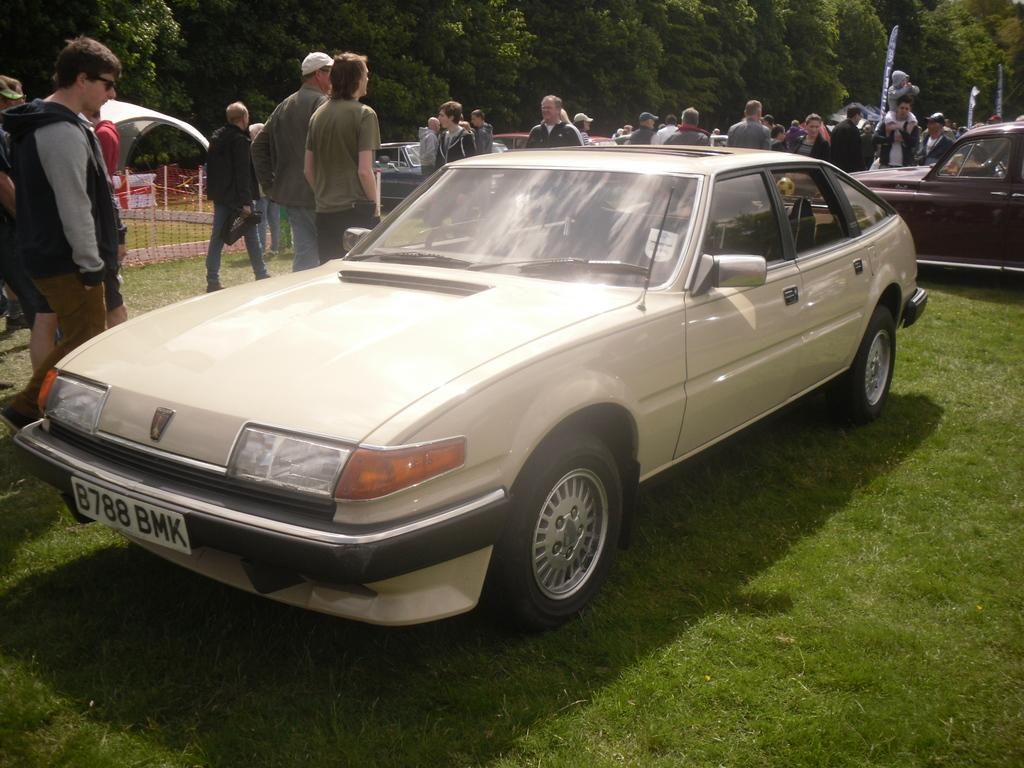Who or what can be seen in the image? There are people in the image. What else is present in the image besides people? There are cars, grass, trees, and plants in the image. Can you describe the natural elements in the image? The grass, trees, and plants are visible in the image. What type of yam is being used to direct traffic in the image? There is no yam present in the image, and therefore no such activity can be observed. 